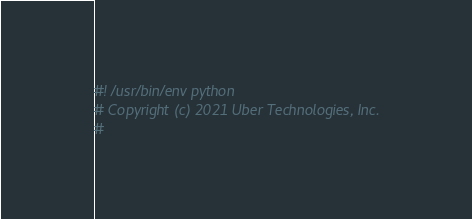<code> <loc_0><loc_0><loc_500><loc_500><_Python_>#! /usr/bin/env python
# Copyright (c) 2021 Uber Technologies, Inc.
#</code> 